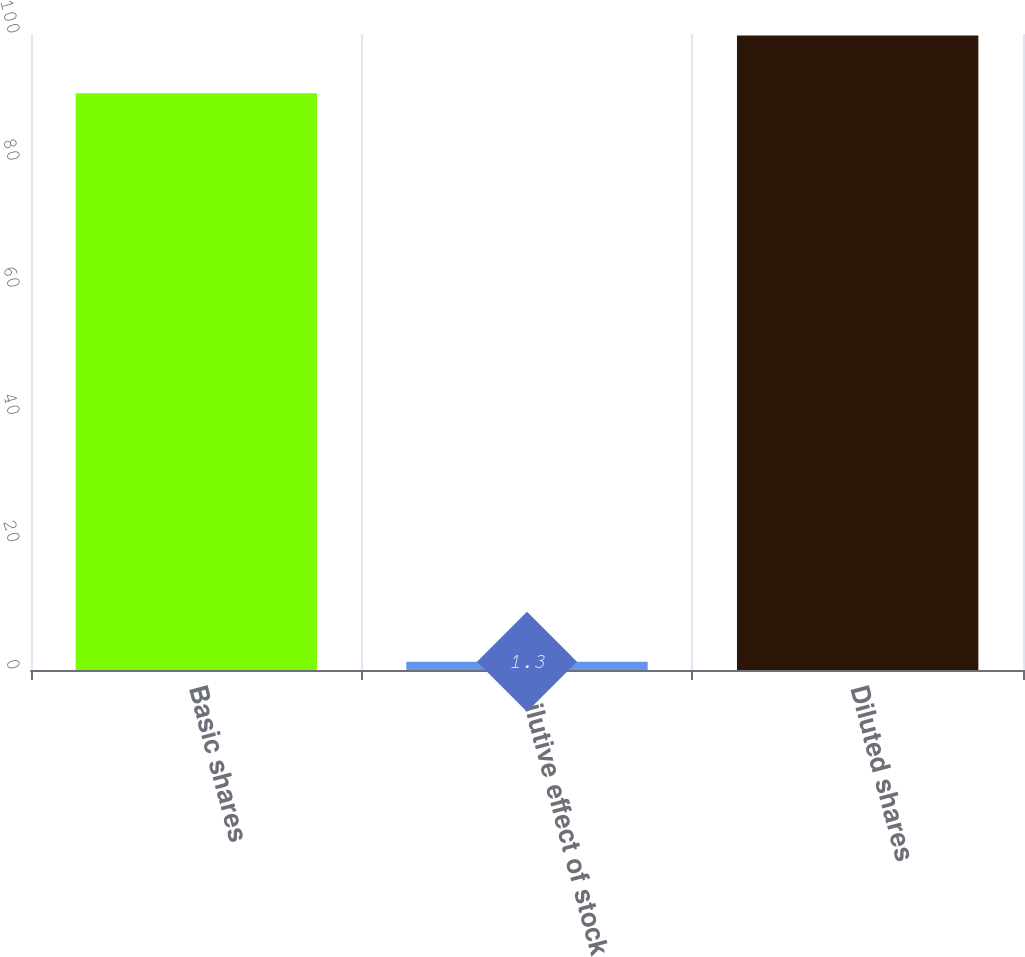Convert chart. <chart><loc_0><loc_0><loc_500><loc_500><bar_chart><fcel>Basic shares<fcel>Dilutive effect of stock<fcel>Diluted shares<nl><fcel>90.7<fcel>1.3<fcel>99.77<nl></chart> 